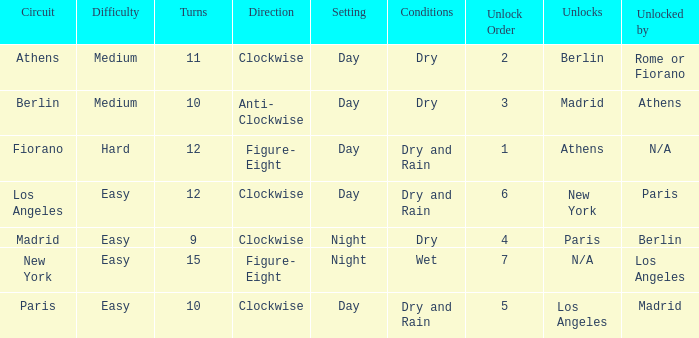What is the least unlock order for the athens circuit? 2.0. 